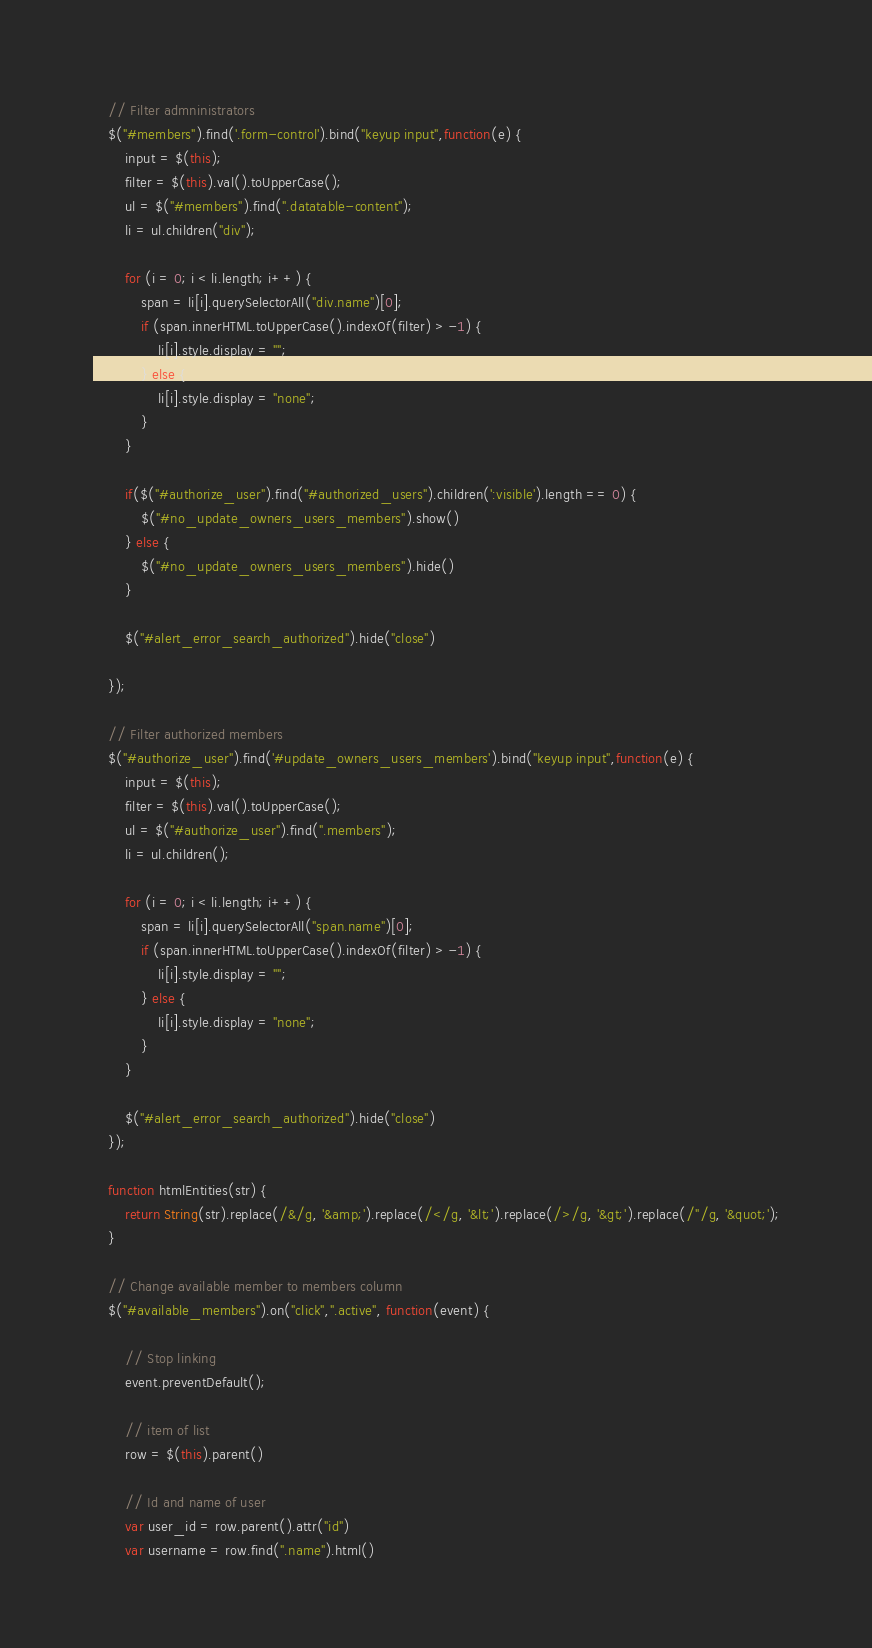<code> <loc_0><loc_0><loc_500><loc_500><_JavaScript_>
    // Filter admninistrators
    $("#members").find('.form-control').bind("keyup input",function(e) {
        input = $(this);
        filter = $(this).val().toUpperCase();
        ul = $("#members").find(".datatable-content");
        li = ul.children("div");

        for (i = 0; i < li.length; i++) {
            span = li[i].querySelectorAll("div.name")[0];
            if (span.innerHTML.toUpperCase().indexOf(filter) > -1) {
                li[i].style.display = "";
            } else {
                li[i].style.display = "none";
            }
        }

        if($("#authorize_user").find("#authorized_users").children(':visible').length == 0) {
            $("#no_update_owners_users_members").show() 
        } else {
            $("#no_update_owners_users_members").hide() 
        }

        $("#alert_error_search_authorized").hide("close")     
      
    });

    // Filter authorized members
    $("#authorize_user").find('#update_owners_users_members').bind("keyup input",function(e) {
        input = $(this);
        filter = $(this).val().toUpperCase();
        ul = $("#authorize_user").find(".members");
        li = ul.children();

        for (i = 0; i < li.length; i++) {
            span = li[i].querySelectorAll("span.name")[0];
            if (span.innerHTML.toUpperCase().indexOf(filter) > -1) {
                li[i].style.display = "";
            } else {
                li[i].style.display = "none";
            }
        }
  
        $("#alert_error_search_authorized").hide("close") 
    });

    function htmlEntities(str) {
        return String(str).replace(/&/g, '&amp;').replace(/</g, '&lt;').replace(/>/g, '&gt;').replace(/"/g, '&quot;');
    }

    // Change available member to members column
    $("#available_members").on("click",".active", function(event) { 

        // Stop linking        
        event.preventDefault();

        // item of list
        row = $(this).parent()

        // Id and name of user
        var user_id = row.parent().attr("id")
        var username = row.find(".name").html()</code> 